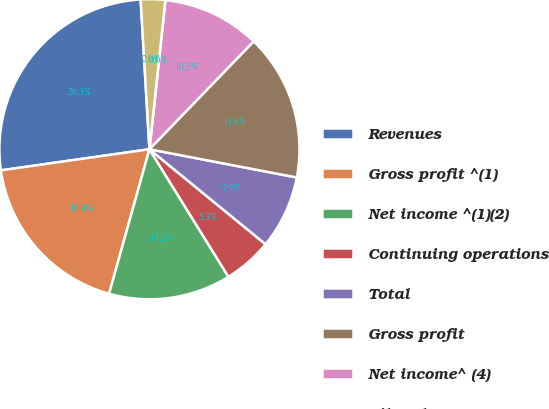<chart> <loc_0><loc_0><loc_500><loc_500><pie_chart><fcel>Revenues<fcel>Gross profit ^(1)<fcel>Net income ^(1)(2)<fcel>Continuing operations<fcel>Total<fcel>Gross profit<fcel>Net income^ (4)<fcel>Diluted<fcel>Basic<nl><fcel>26.31%<fcel>18.42%<fcel>13.16%<fcel>5.26%<fcel>7.9%<fcel>15.79%<fcel>10.53%<fcel>0.0%<fcel>2.63%<nl></chart> 